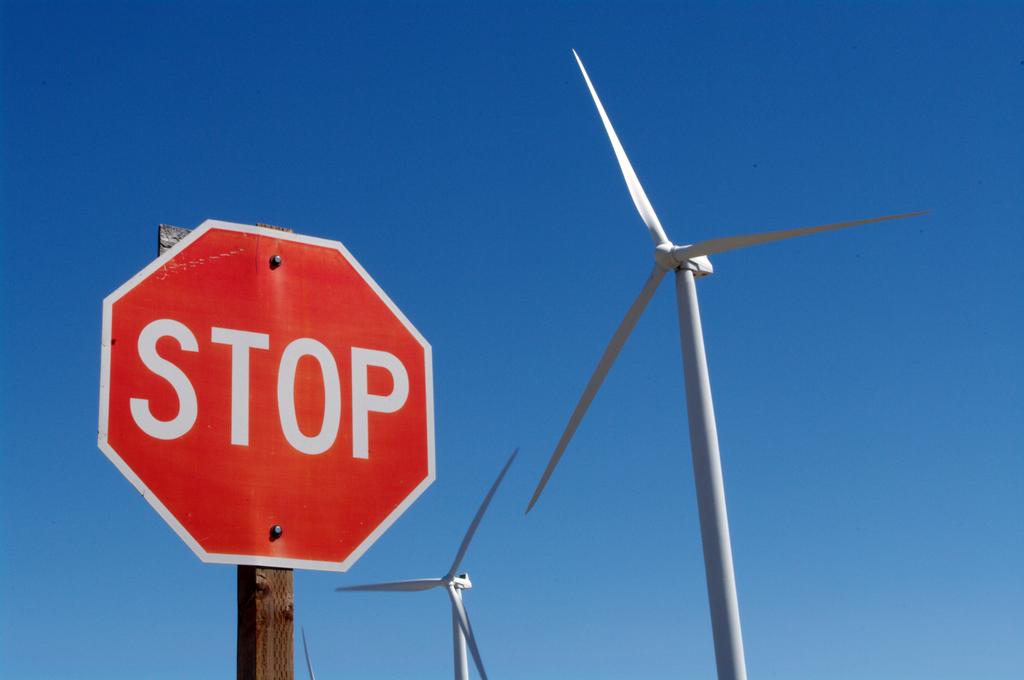What kind of traffic sign is this?
Provide a succinct answer. Stop. What word is on the sign?
Make the answer very short. Stop. 